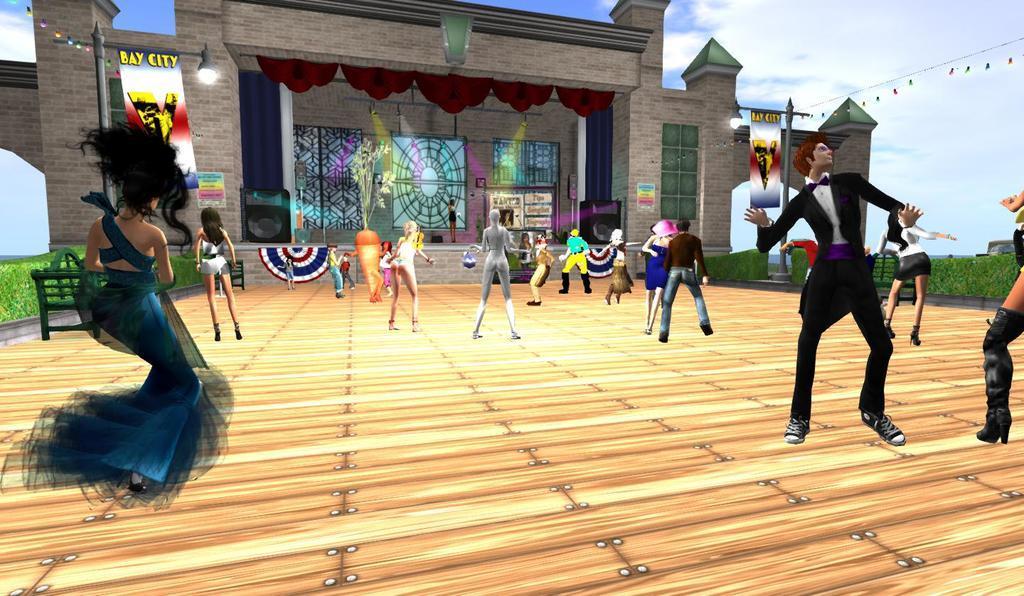In one or two sentences, can you explain what this image depicts? It is an animated image. In this image we can see the people dancing on the wooden floor. We can also see the benches, light poles, banners, lights, plant and also the building. In the background there is sky with the clouds. 